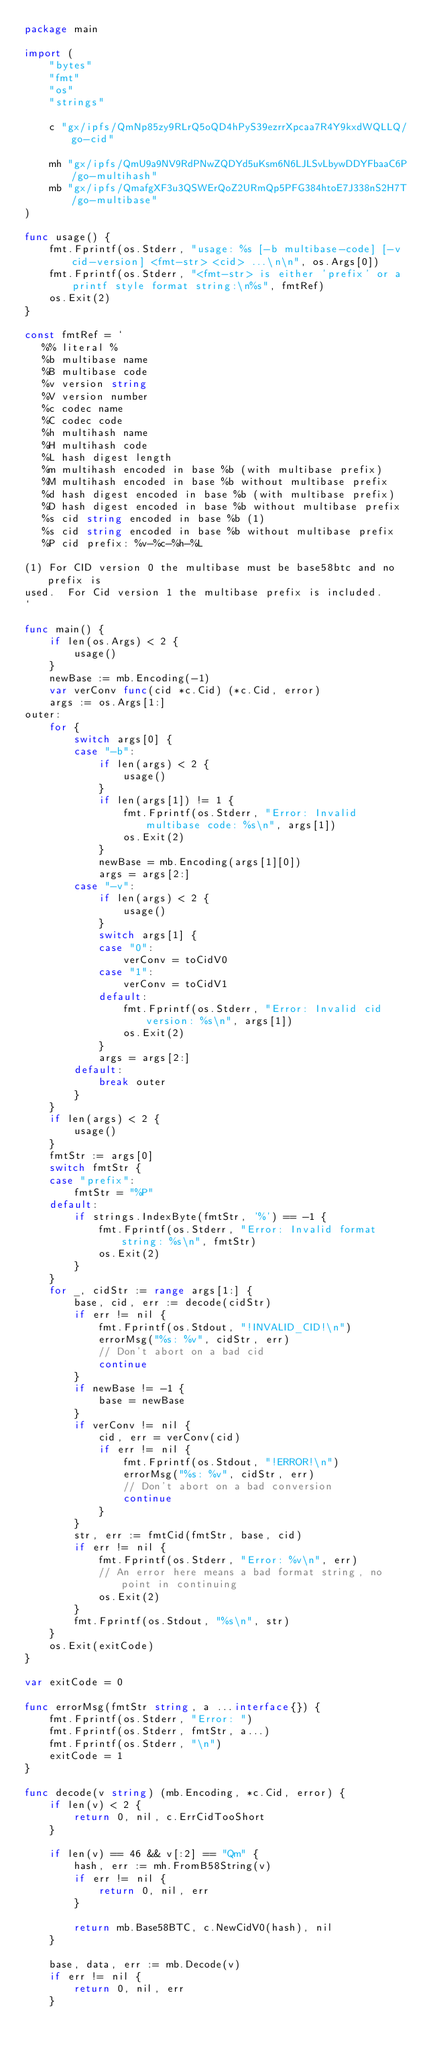Convert code to text. <code><loc_0><loc_0><loc_500><loc_500><_Go_>package main

import (
	"bytes"
	"fmt"
	"os"
	"strings"

	c "gx/ipfs/QmNp85zy9RLrQ5oQD4hPyS39ezrrXpcaa7R4Y9kxdWQLLQ/go-cid"

	mh "gx/ipfs/QmU9a9NV9RdPNwZQDYd5uKsm6N6LJLSvLbywDDYFbaaC6P/go-multihash"
	mb "gx/ipfs/QmafgXF3u3QSWErQoZ2URmQp5PFG384htoE7J338nS2H7T/go-multibase"
)

func usage() {
	fmt.Fprintf(os.Stderr, "usage: %s [-b multibase-code] [-v cid-version] <fmt-str> <cid> ...\n\n", os.Args[0])
	fmt.Fprintf(os.Stderr, "<fmt-str> is either 'prefix' or a printf style format string:\n%s", fmtRef)
	os.Exit(2)
}

const fmtRef = `
   %% literal %
   %b multibase name 
   %B multibase code
   %v version string
   %V version number
   %c codec name
   %C codec code
   %h multihash name
   %H multihash code
   %L hash digest length
   %m multihash encoded in base %b (with multibase prefix)
   %M multihash encoded in base %b without multibase prefix
   %d hash digest encoded in base %b (with multibase prefix)
   %D hash digest encoded in base %b without multibase prefix
   %s cid string encoded in base %b (1)
   %s cid string encoded in base %b without multibase prefix
   %P cid prefix: %v-%c-%h-%L

(1) For CID version 0 the multibase must be base58btc and no prefix is
used.  For Cid version 1 the multibase prefix is included.
`

func main() {
	if len(os.Args) < 2 {
		usage()
	}
	newBase := mb.Encoding(-1)
	var verConv func(cid *c.Cid) (*c.Cid, error)
	args := os.Args[1:]
outer:
	for {
		switch args[0] {
		case "-b":
			if len(args) < 2 {
				usage()
			}
			if len(args[1]) != 1 {
				fmt.Fprintf(os.Stderr, "Error: Invalid multibase code: %s\n", args[1])
				os.Exit(2)
			}
			newBase = mb.Encoding(args[1][0])
			args = args[2:]
		case "-v":
			if len(args) < 2 {
				usage()
			}
			switch args[1] {
			case "0":
				verConv = toCidV0
			case "1":
				verConv = toCidV1
			default:
				fmt.Fprintf(os.Stderr, "Error: Invalid cid version: %s\n", args[1])
				os.Exit(2)
			}
			args = args[2:]
		default:
			break outer
		}
	}
	if len(args) < 2 {
		usage()
	}
	fmtStr := args[0]
	switch fmtStr {
	case "prefix":
		fmtStr = "%P"
	default:
		if strings.IndexByte(fmtStr, '%') == -1 {
			fmt.Fprintf(os.Stderr, "Error: Invalid format string: %s\n", fmtStr)
			os.Exit(2)
		}
	}
	for _, cidStr := range args[1:] {
		base, cid, err := decode(cidStr)
		if err != nil {
			fmt.Fprintf(os.Stdout, "!INVALID_CID!\n")
			errorMsg("%s: %v", cidStr, err)
			// Don't abort on a bad cid
			continue
		}
		if newBase != -1 {
			base = newBase
		}
		if verConv != nil {
			cid, err = verConv(cid)
			if err != nil {
				fmt.Fprintf(os.Stdout, "!ERROR!\n")
				errorMsg("%s: %v", cidStr, err)
				// Don't abort on a bad conversion
				continue
			}
		}
		str, err := fmtCid(fmtStr, base, cid)
		if err != nil {
			fmt.Fprintf(os.Stderr, "Error: %v\n", err)
			// An error here means a bad format string, no point in continuing
			os.Exit(2)
		}
		fmt.Fprintf(os.Stdout, "%s\n", str)
	}
	os.Exit(exitCode)
}

var exitCode = 0

func errorMsg(fmtStr string, a ...interface{}) {
	fmt.Fprintf(os.Stderr, "Error: ")
	fmt.Fprintf(os.Stderr, fmtStr, a...)
	fmt.Fprintf(os.Stderr, "\n")
	exitCode = 1
}

func decode(v string) (mb.Encoding, *c.Cid, error) {
	if len(v) < 2 {
		return 0, nil, c.ErrCidTooShort
	}

	if len(v) == 46 && v[:2] == "Qm" {
		hash, err := mh.FromB58String(v)
		if err != nil {
			return 0, nil, err
		}

		return mb.Base58BTC, c.NewCidV0(hash), nil
	}

	base, data, err := mb.Decode(v)
	if err != nil {
		return 0, nil, err
	}
</code> 